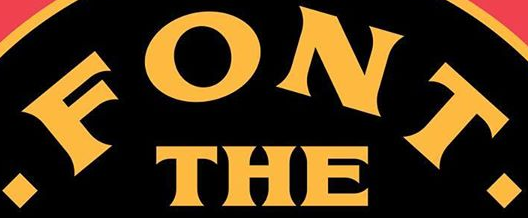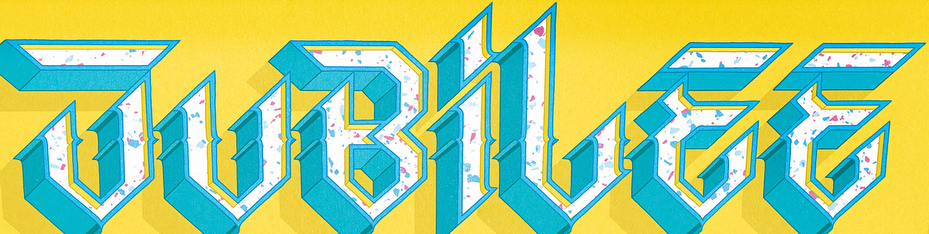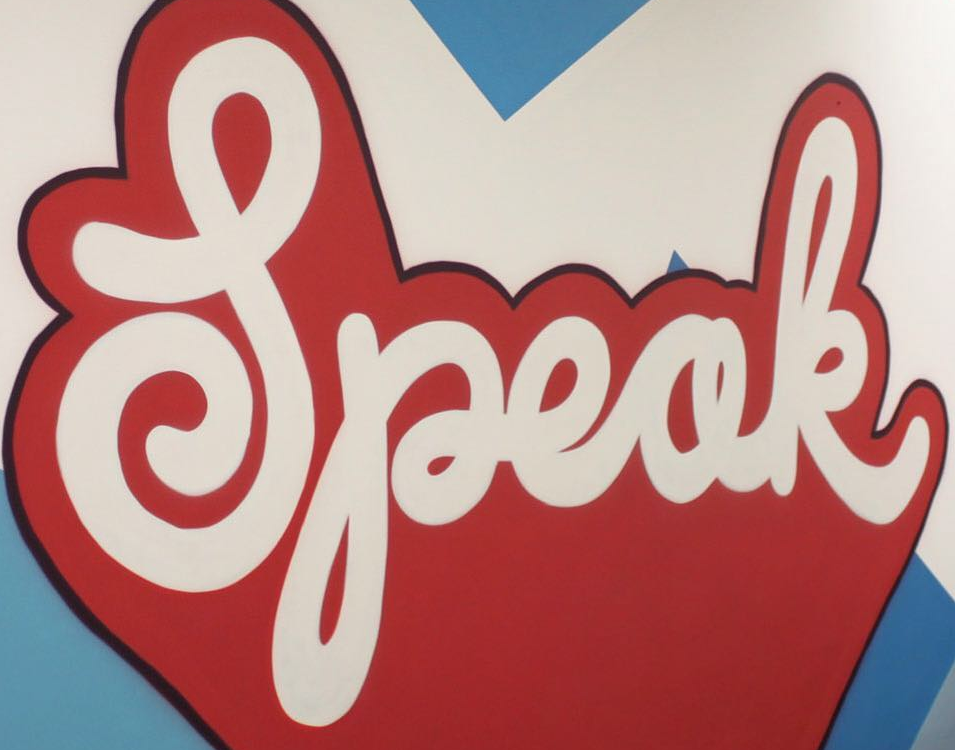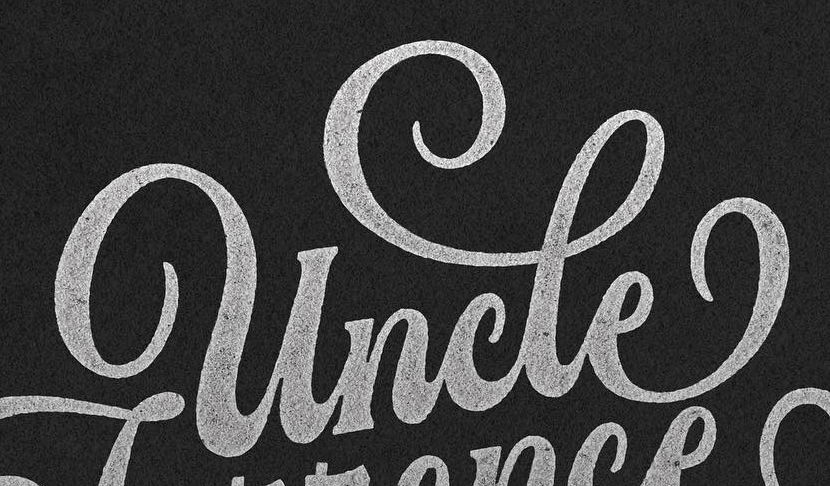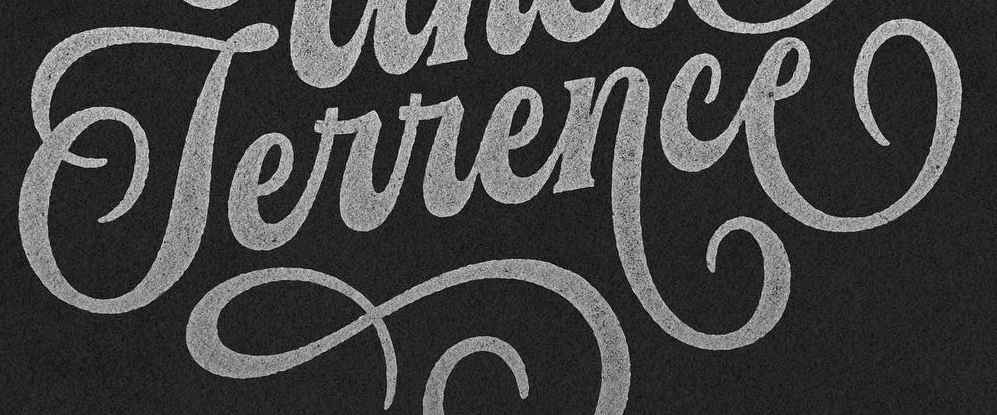What text appears in these images from left to right, separated by a semicolon? .FONT.; JUBiLEE; Speak; uncle; Terrence 